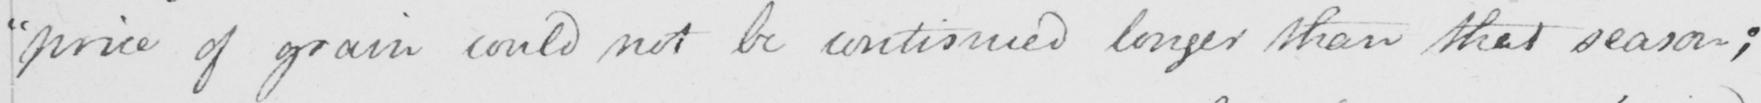What text is written in this handwritten line? " price of grain could not be continued longer than that season ; 